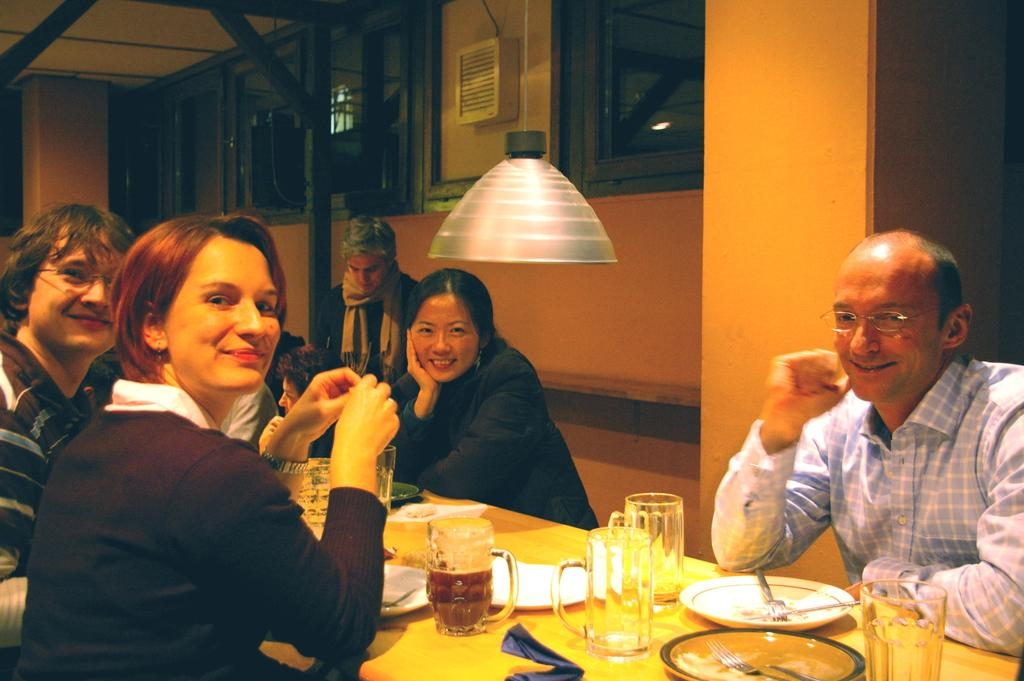How many people are in the image? There is a group of people in the image. What are the people doing in the image? The people are sitting on chairs. Where are the chairs located in relation to the table? The chairs are in front of a table. What can be found on the table in the image? There are plates, glasses, and other objects on the table. What type of frame is used to support the knowledge in the image? There is no frame or knowledge present in the image; it features a group of people sitting in chairs in front of a table with plates, glasses, and other objects. 